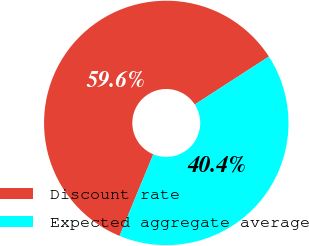Convert chart. <chart><loc_0><loc_0><loc_500><loc_500><pie_chart><fcel>Discount rate<fcel>Expected aggregate average<nl><fcel>59.62%<fcel>40.38%<nl></chart> 